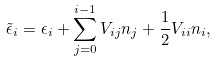<formula> <loc_0><loc_0><loc_500><loc_500>\tilde { \epsilon } _ { i } = \epsilon _ { i } + \sum _ { j = 0 } ^ { i - 1 } V _ { i j } n _ { j } + \frac { 1 } { 2 } V _ { i i } n _ { i } ,</formula> 